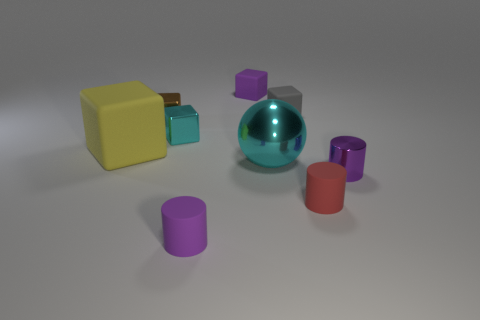Are there any other things of the same color as the big matte thing?
Provide a succinct answer. No. What number of cyan things are made of the same material as the brown block?
Give a very brief answer. 2. How many metallic things are blue balls or tiny purple cylinders?
Offer a terse response. 1. There is a brown block that is the same size as the cyan cube; what is its material?
Your answer should be very brief. Metal. Are there any small cyan blocks that have the same material as the small brown cube?
Offer a very short reply. Yes. What shape is the cyan object that is in front of the big matte cube that is behind the big thing that is to the right of the large yellow cube?
Offer a very short reply. Sphere. There is a shiny cylinder; does it have the same size as the yellow rubber object that is left of the red rubber cylinder?
Provide a succinct answer. No. There is a matte object that is on the left side of the purple block and to the right of the yellow thing; what is its shape?
Offer a terse response. Cylinder. How many large objects are brown objects or blue matte objects?
Offer a very short reply. 0. Is the number of rubber things on the right side of the purple rubber cylinder the same as the number of large rubber things that are behind the tiny purple cube?
Your response must be concise. No. 